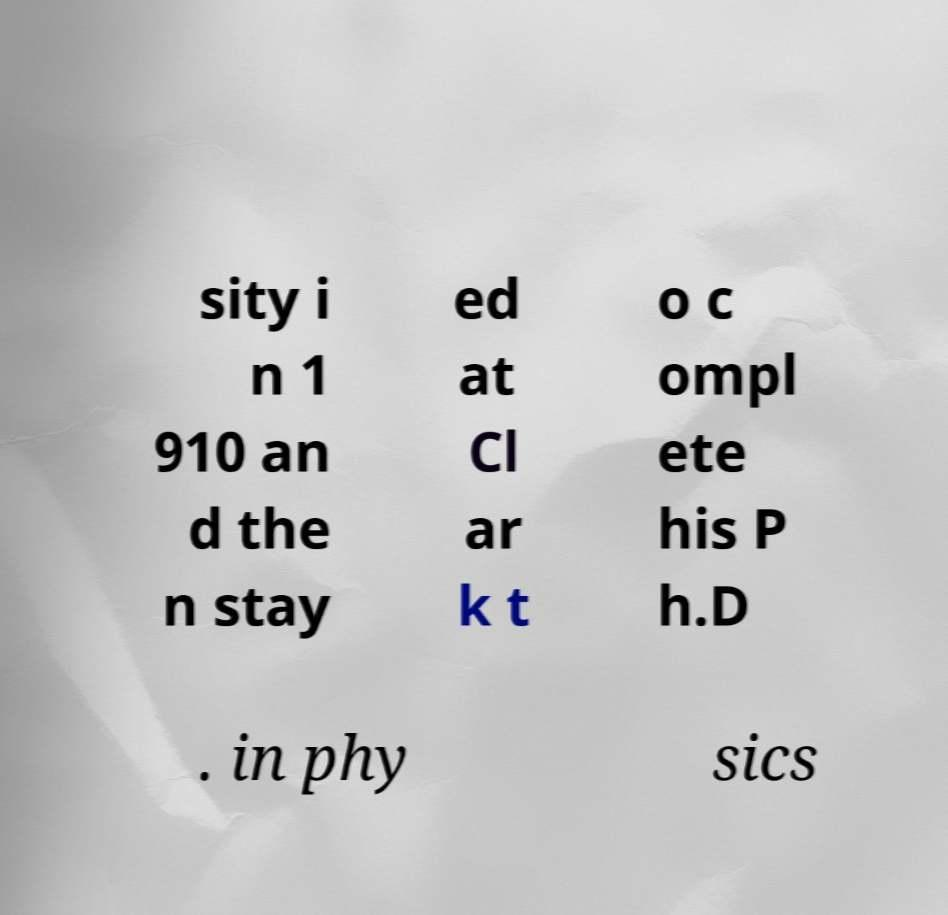Could you extract and type out the text from this image? sity i n 1 910 an d the n stay ed at Cl ar k t o c ompl ete his P h.D . in phy sics 